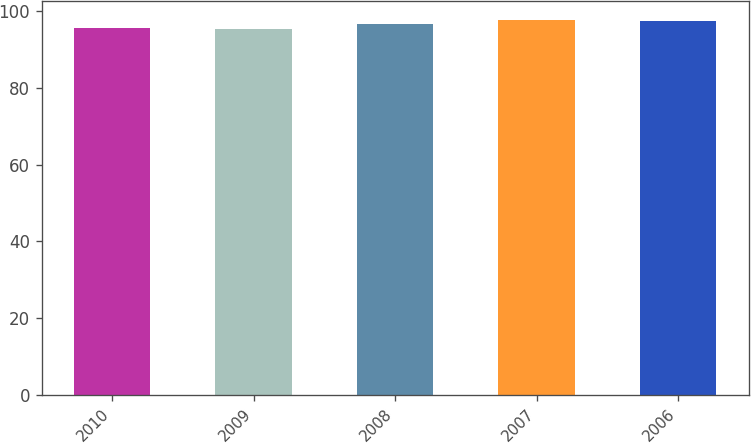Convert chart to OTSL. <chart><loc_0><loc_0><loc_500><loc_500><bar_chart><fcel>2010<fcel>2009<fcel>2008<fcel>2007<fcel>2006<nl><fcel>95.71<fcel>95.5<fcel>96.7<fcel>97.71<fcel>97.5<nl></chart> 